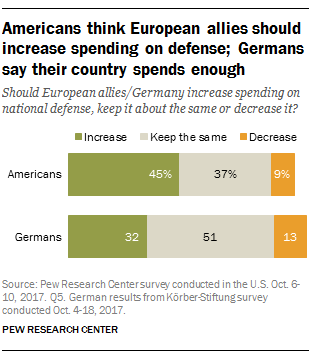Specify some key components in this picture. It has been determined that two countries have been considered. According to a recent survey, 77% of Americans and Germans support an increase in allies. 